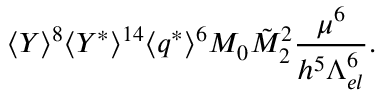Convert formula to latex. <formula><loc_0><loc_0><loc_500><loc_500>\langle Y \rangle ^ { 8 } \langle Y ^ { * } \rangle ^ { 1 4 } \langle q ^ { * } \rangle ^ { 6 } M _ { 0 } \tilde { M } _ { 2 } ^ { 2 } \frac { \mu ^ { 6 } } { h ^ { 5 } \Lambda _ { e l } ^ { 6 } } .</formula> 